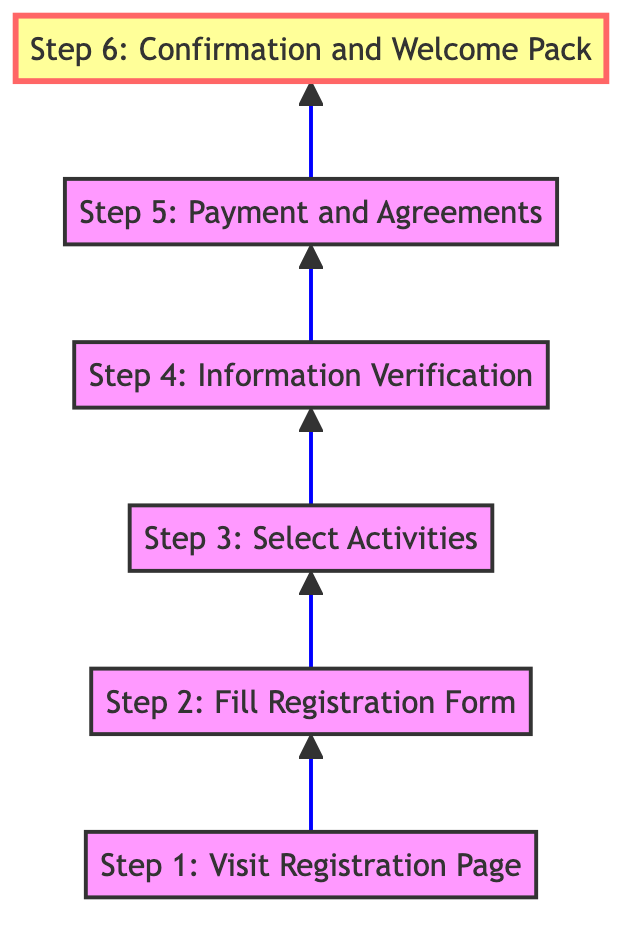What is the first step in the registration process? The first step is indicated at the bottom of the diagram as "Step 1: Visit Registration Page." This is the starting point before any other actions can take place.
Answer: Step 1: Visit Registration Page How many steps are there in total? By counting the nodes in the diagram, there are six distinct steps listed from Step 1 to Step 6.
Answer: 6 What do you need to complete before receiving the confirmation? You must complete "Step 5: Payment and Agreements," which involves settling payment and agreeing to safety and inclusion policies before you can receive the confirmation.
Answer: Step 5: Payment and Agreements What is contained in the welcome pack? The welcome pack includes event details, safety protocols, and inclusivity measures as stated in "Step 6: Confirmation and Welcome Pack."
Answer: Event details, safety protocols, and inclusivity measures What step comes immediately after selecting activities? "Step 4: Information Verification" immediately follows "Step 3: Select Activities," indicating that verification occurs after you choose the activities for your child.
Answer: Step 4: Information Verification Which step requires filling out personal information? "Step 2: Fill Registration Form" is where you fill out essential details such as your child's name, age, and other relevant information, making it the step that requires personal information.
Answer: Step 2: Fill Registration Form What action must be taken after information verification? Following "Step 4: Information Verification," the next action is "Step 5: Payment and Agreements," which involves completing the payment process and agreeing to terms.
Answer: Step 5: Payment and Agreements What type of activities can be selected in the process? "Step 3: Select Activities" allows you to choose from various activities such as Music Classes, Art Workshops, or Sports tailored to your child's interests and needs.
Answer: Music Classes, Art Workshops, or Sports When does the process end? The process concludes at "Step 6: Confirmation and Welcome Pack," where you receive your confirmation email and accompanying materials.
Answer: Step 6: Confirmation and Welcome Pack 